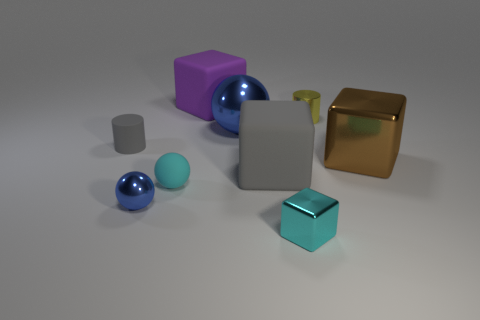Add 1 small gray objects. How many objects exist? 10 Subtract all blocks. How many objects are left? 5 Add 7 big gray spheres. How many big gray spheres exist? 7 Subtract 0 green blocks. How many objects are left? 9 Subtract all tiny blue metal things. Subtract all tiny gray cylinders. How many objects are left? 7 Add 2 yellow cylinders. How many yellow cylinders are left? 3 